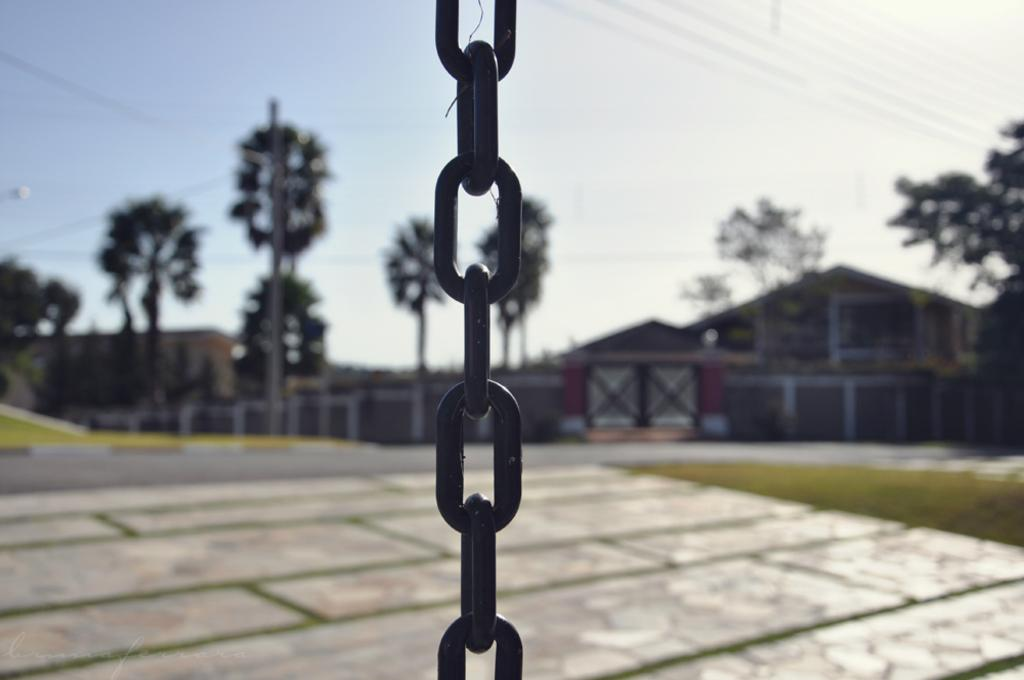What object can be seen in the image that resembles a chain? There is a chain in the image. What type of structure can be seen in the background of the image? There is a building in the background of the image. What type of natural environment is visible in the background of the image? There are trees in the background of the image. What type of man-made structure is visible at the bottom of the image? There is a road visible at the bottom of the image. What type of soda is being served in the class in the image? There is no class or soda present in the image. 